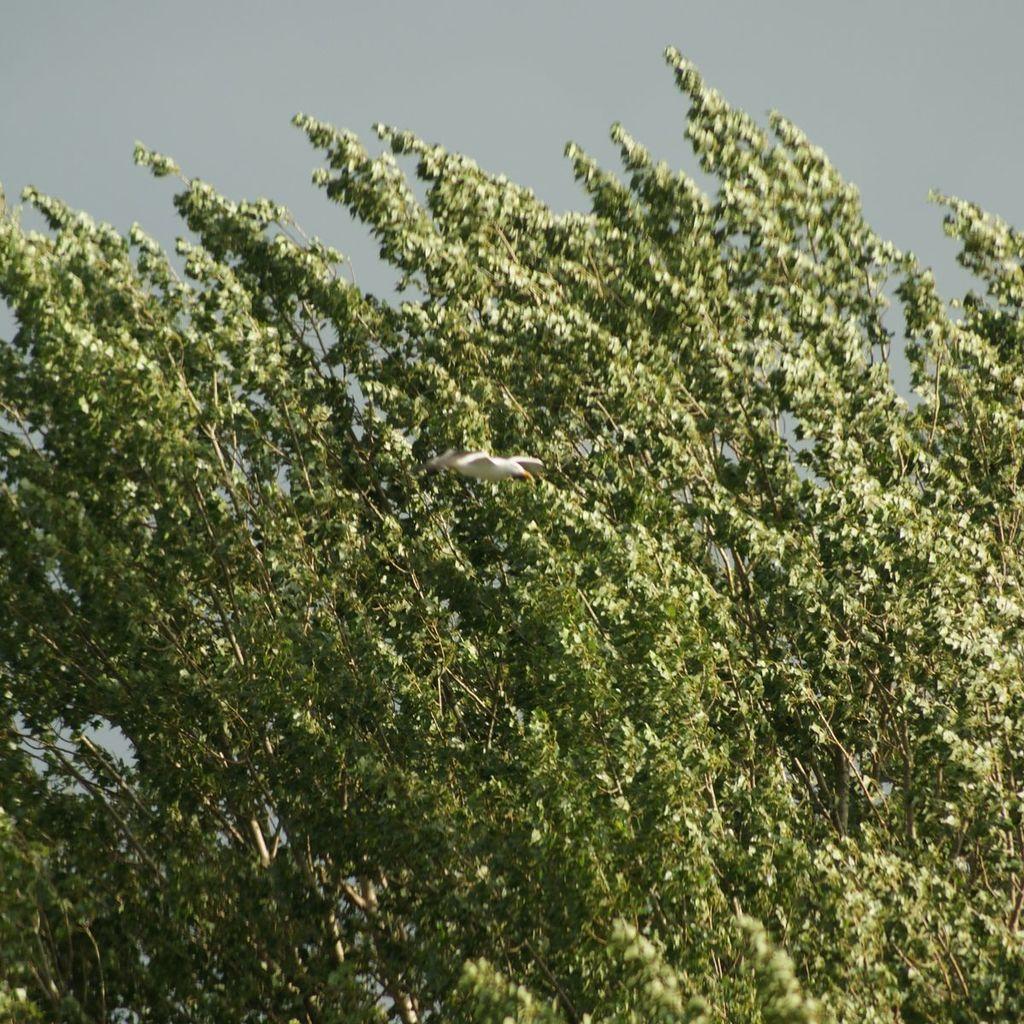In one or two sentences, can you explain what this image depicts? This image consists of a tree and we can see a bird flying in the air. At the top, there is sky. 